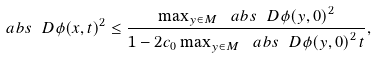Convert formula to latex. <formula><loc_0><loc_0><loc_500><loc_500>\ a b s { \ D \phi ( x , t ) } ^ { 2 } \leq \frac { \max _ { y \in M } \ a b s { \ D \phi ( y , 0 ) } ^ { 2 } } { 1 - 2 c _ { 0 } \max _ { y \in M } \ a b s { \ D \phi ( y , 0 ) } ^ { 2 } \, t } ,</formula> 